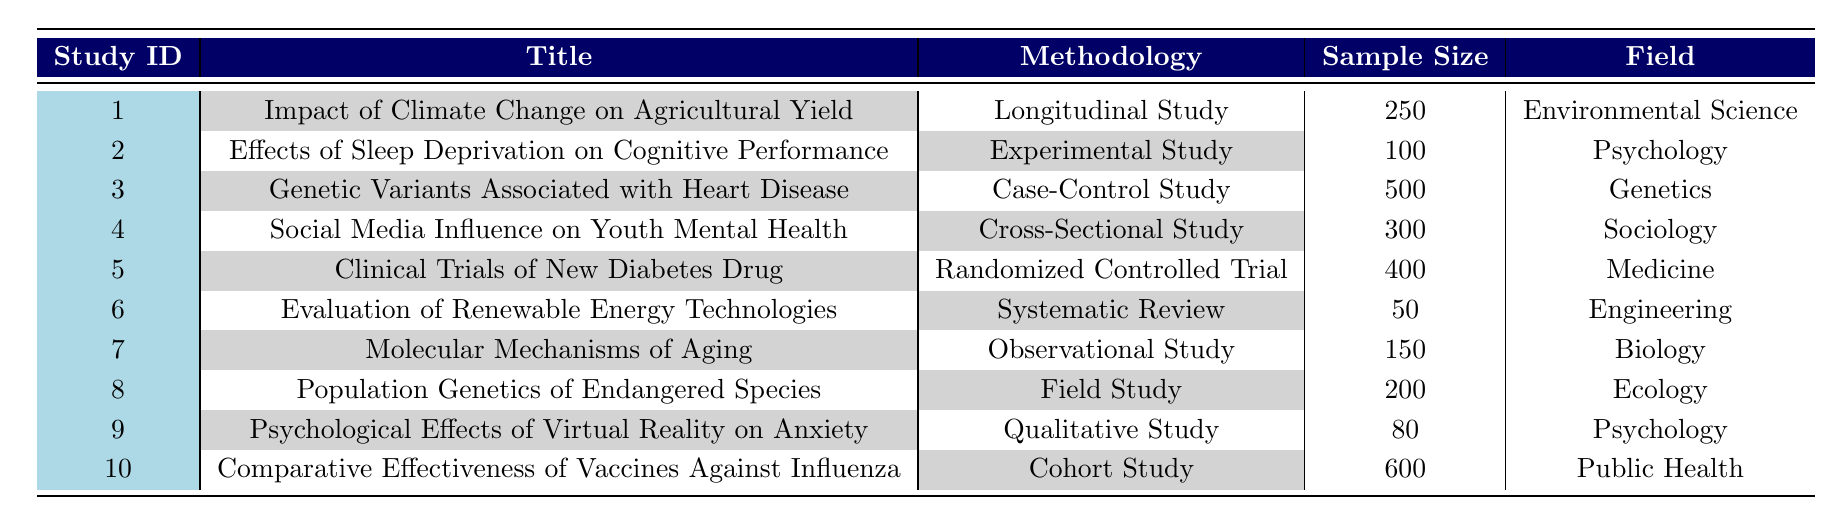What is the methodology used in the study titled "Impact of Climate Change on Agricultural Yield"? The title of the study "Impact of Climate Change on Agricultural Yield" corresponds to Study ID 1, and the methodology column indicates it is a "Longitudinal Study".
Answer: Longitudinal Study How many studies used an Experimental methodology in 2022? Referring to the table, only one study (Study ID 2) titled "Effects of Sleep Deprivation on Cognitive Performance" utilizes the Experimental methodology.
Answer: 1 Is the sample size for the study "Population Genetics of Endangered Species" greater than 200? The study "Population Genetics of Endangered Species" has a sample size of 200 listed in the table, which is not greater than 200, hence the answer is no.
Answer: No Which field of research has the highest sample size according to the table? Looking through the sample sizes, "Comparative Effectiveness of Vaccines Against Influenza" (Study ID 10) in the field of Public Health has the highest sample size of 600. Hence it is the field with the highest number.
Answer: Public Health Calculate the average sample size for the studies listed in the table. To find the average, first, we sum all the sample sizes: 250 + 100 + 500 + 300 + 400 + 50 + 150 + 200 + 80 + 600 = 2680. There are 10 studies in total, so the average sample size is 2680 / 10 = 268.
Answer: 268 How many studies fall under the field of Psychology? There are two studies listed under the field of Psychology: "Effects of Sleep Deprivation on Cognitive Performance" and "Psychological Effects of Virtual Reality on Anxiety".
Answer: 2 Is there a study using a Systematic Review methodology? Yes, there is a study titled "Evaluation of Renewable Energy Technologies" that uses a Systematic Review methodology as per the table.
Answer: Yes Identify the second largest sample size in the table and the corresponding study title. The sample sizes listed are 250, 100, 500, 300, 400, 50, 150, 200, 80, and 600. The second largest sample size is 500, which corresponds to the study titled "Genetic Variants Associated with Heart Disease" (Study ID 3).
Answer: Genetic Variants Associated with Heart Disease What type of study is the "Clinical Trials of New Diabetes Drug"? The study "Clinical Trials of New Diabetes Drug" is identified by Study ID 5, where the methodology indicated is "Randomized Controlled Trial".
Answer: Randomized Controlled Trial 